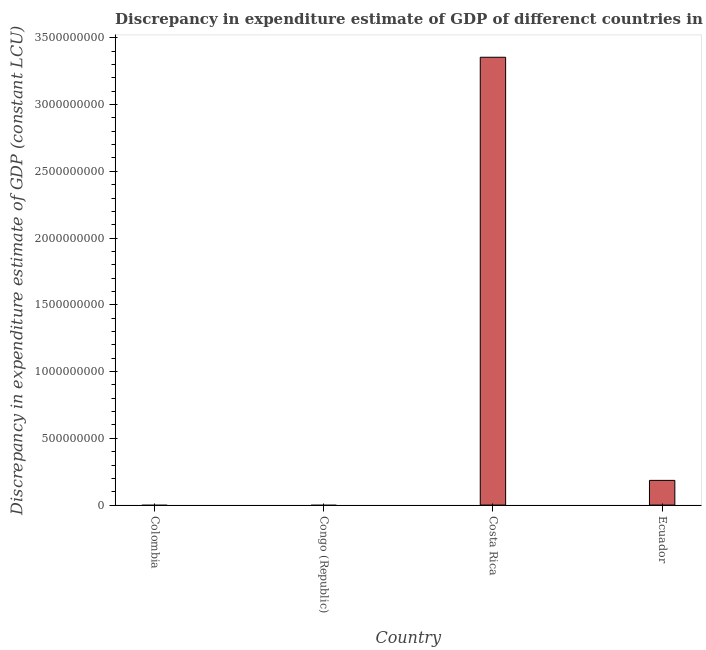What is the title of the graph?
Your answer should be compact. Discrepancy in expenditure estimate of GDP of differenct countries in 1961. What is the label or title of the X-axis?
Offer a terse response. Country. What is the label or title of the Y-axis?
Offer a terse response. Discrepancy in expenditure estimate of GDP (constant LCU). What is the discrepancy in expenditure estimate of gdp in Congo (Republic)?
Provide a succinct answer. 0. Across all countries, what is the maximum discrepancy in expenditure estimate of gdp?
Offer a terse response. 3.35e+09. In which country was the discrepancy in expenditure estimate of gdp maximum?
Provide a succinct answer. Costa Rica. What is the sum of the discrepancy in expenditure estimate of gdp?
Make the answer very short. 3.54e+09. What is the difference between the discrepancy in expenditure estimate of gdp in Costa Rica and Ecuador?
Give a very brief answer. 3.17e+09. What is the average discrepancy in expenditure estimate of gdp per country?
Ensure brevity in your answer.  8.85e+08. What is the median discrepancy in expenditure estimate of gdp?
Your answer should be compact. 9.24e+07. In how many countries, is the discrepancy in expenditure estimate of gdp greater than 200000000 LCU?
Provide a succinct answer. 1. What is the ratio of the discrepancy in expenditure estimate of gdp in Costa Rica to that in Ecuador?
Offer a very short reply. 18.14. What is the difference between the highest and the lowest discrepancy in expenditure estimate of gdp?
Your response must be concise. 3.35e+09. How many bars are there?
Your answer should be compact. 2. What is the difference between two consecutive major ticks on the Y-axis?
Provide a succinct answer. 5.00e+08. Are the values on the major ticks of Y-axis written in scientific E-notation?
Offer a very short reply. No. What is the Discrepancy in expenditure estimate of GDP (constant LCU) in Congo (Republic)?
Your response must be concise. 0. What is the Discrepancy in expenditure estimate of GDP (constant LCU) of Costa Rica?
Your answer should be compact. 3.35e+09. What is the Discrepancy in expenditure estimate of GDP (constant LCU) in Ecuador?
Provide a succinct answer. 1.85e+08. What is the difference between the Discrepancy in expenditure estimate of GDP (constant LCU) in Costa Rica and Ecuador?
Offer a terse response. 3.17e+09. What is the ratio of the Discrepancy in expenditure estimate of GDP (constant LCU) in Costa Rica to that in Ecuador?
Offer a very short reply. 18.14. 